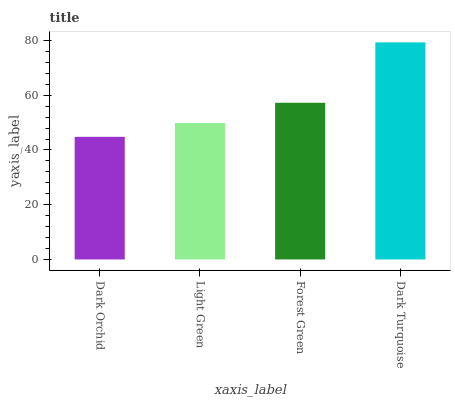Is Dark Orchid the minimum?
Answer yes or no. Yes. Is Dark Turquoise the maximum?
Answer yes or no. Yes. Is Light Green the minimum?
Answer yes or no. No. Is Light Green the maximum?
Answer yes or no. No. Is Light Green greater than Dark Orchid?
Answer yes or no. Yes. Is Dark Orchid less than Light Green?
Answer yes or no. Yes. Is Dark Orchid greater than Light Green?
Answer yes or no. No. Is Light Green less than Dark Orchid?
Answer yes or no. No. Is Forest Green the high median?
Answer yes or no. Yes. Is Light Green the low median?
Answer yes or no. Yes. Is Light Green the high median?
Answer yes or no. No. Is Dark Turquoise the low median?
Answer yes or no. No. 